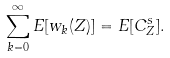Convert formula to latex. <formula><loc_0><loc_0><loc_500><loc_500>\sum _ { k = 0 } ^ { \infty } E [ w _ { k } ( Z ) ] = E [ C _ { Z } ^ { s } ] .</formula> 